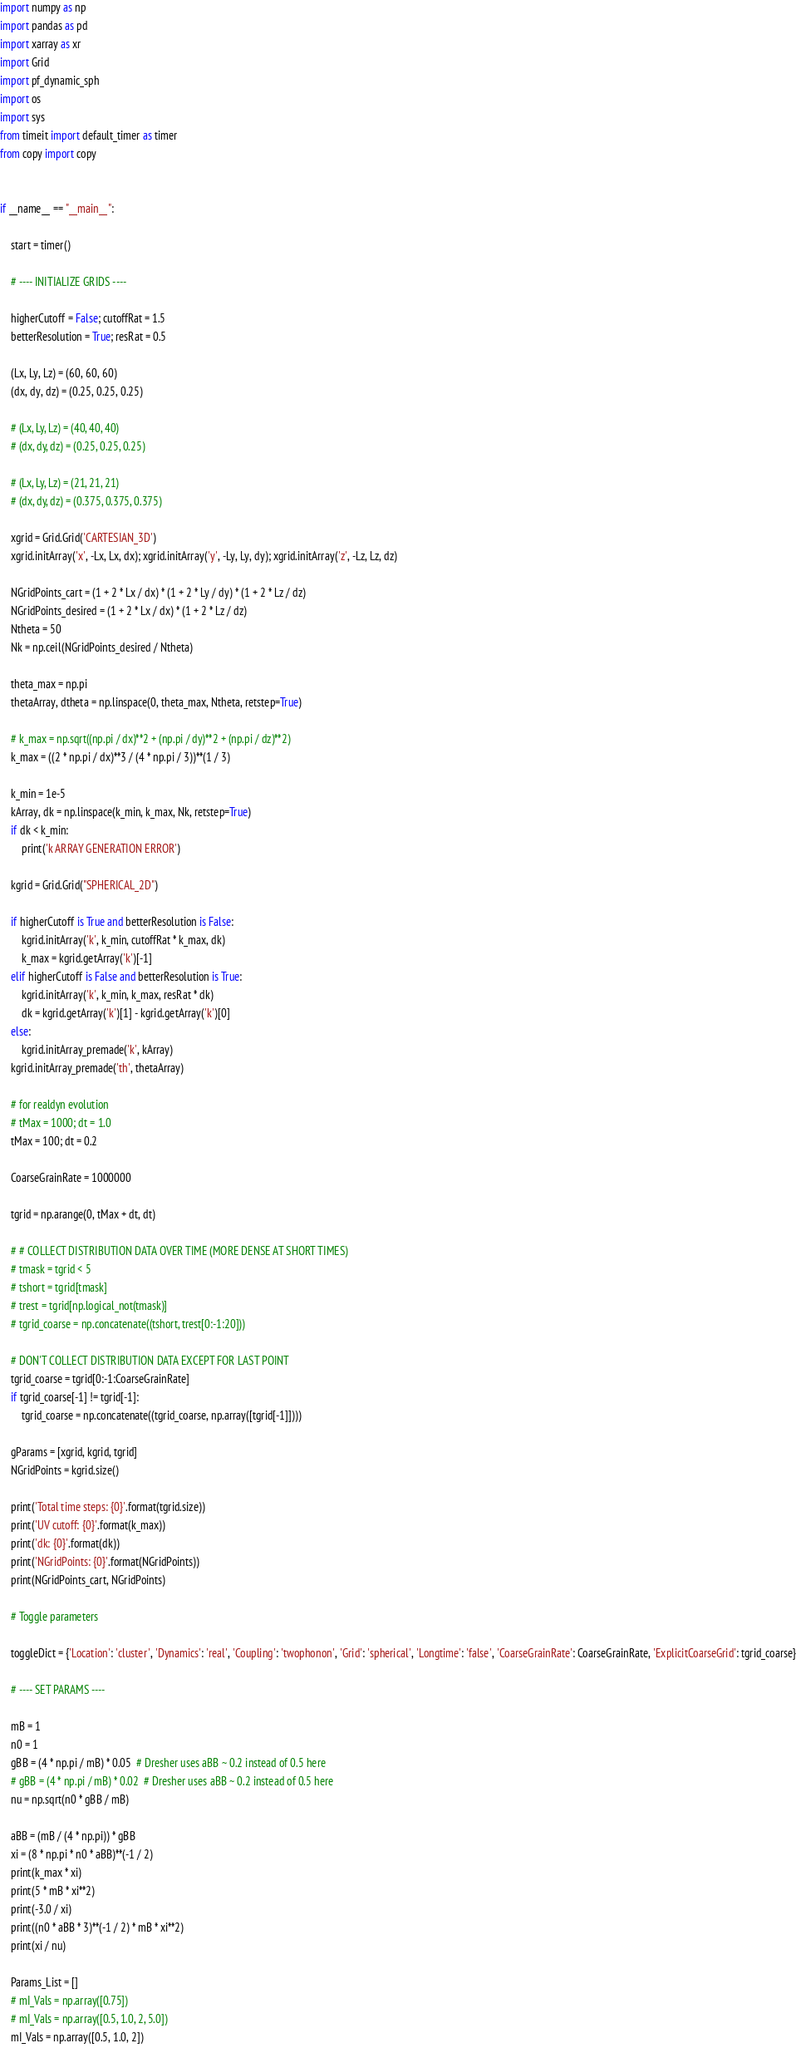Convert code to text. <code><loc_0><loc_0><loc_500><loc_500><_Python_>import numpy as np
import pandas as pd
import xarray as xr
import Grid
import pf_dynamic_sph
import os
import sys
from timeit import default_timer as timer
from copy import copy


if __name__ == "__main__":

    start = timer()

    # ---- INITIALIZE GRIDS ----

    higherCutoff = False; cutoffRat = 1.5
    betterResolution = True; resRat = 0.5

    (Lx, Ly, Lz) = (60, 60, 60)
    (dx, dy, dz) = (0.25, 0.25, 0.25)

    # (Lx, Ly, Lz) = (40, 40, 40)
    # (dx, dy, dz) = (0.25, 0.25, 0.25)

    # (Lx, Ly, Lz) = (21, 21, 21)
    # (dx, dy, dz) = (0.375, 0.375, 0.375)

    xgrid = Grid.Grid('CARTESIAN_3D')
    xgrid.initArray('x', -Lx, Lx, dx); xgrid.initArray('y', -Ly, Ly, dy); xgrid.initArray('z', -Lz, Lz, dz)

    NGridPoints_cart = (1 + 2 * Lx / dx) * (1 + 2 * Ly / dy) * (1 + 2 * Lz / dz)
    NGridPoints_desired = (1 + 2 * Lx / dx) * (1 + 2 * Lz / dz)
    Ntheta = 50
    Nk = np.ceil(NGridPoints_desired / Ntheta)

    theta_max = np.pi
    thetaArray, dtheta = np.linspace(0, theta_max, Ntheta, retstep=True)

    # k_max = np.sqrt((np.pi / dx)**2 + (np.pi / dy)**2 + (np.pi / dz)**2)
    k_max = ((2 * np.pi / dx)**3 / (4 * np.pi / 3))**(1 / 3)

    k_min = 1e-5
    kArray, dk = np.linspace(k_min, k_max, Nk, retstep=True)
    if dk < k_min:
        print('k ARRAY GENERATION ERROR')

    kgrid = Grid.Grid("SPHERICAL_2D")

    if higherCutoff is True and betterResolution is False:
        kgrid.initArray('k', k_min, cutoffRat * k_max, dk)
        k_max = kgrid.getArray('k')[-1]
    elif higherCutoff is False and betterResolution is True:
        kgrid.initArray('k', k_min, k_max, resRat * dk)
        dk = kgrid.getArray('k')[1] - kgrid.getArray('k')[0]
    else:
        kgrid.initArray_premade('k', kArray)
    kgrid.initArray_premade('th', thetaArray)

    # for realdyn evolution
    # tMax = 1000; dt = 1.0
    tMax = 100; dt = 0.2

    CoarseGrainRate = 1000000

    tgrid = np.arange(0, tMax + dt, dt)

    # # COLLECT DISTRIBUTION DATA OVER TIME (MORE DENSE AT SHORT TIMES)
    # tmask = tgrid < 5
    # tshort = tgrid[tmask]
    # trest = tgrid[np.logical_not(tmask)]
    # tgrid_coarse = np.concatenate((tshort, trest[0:-1:20]))

    # DON'T COLLECT DISTRIBUTION DATA EXCEPT FOR LAST POINT
    tgrid_coarse = tgrid[0:-1:CoarseGrainRate]
    if tgrid_coarse[-1] != tgrid[-1]:
        tgrid_coarse = np.concatenate((tgrid_coarse, np.array([tgrid[-1]])))

    gParams = [xgrid, kgrid, tgrid]
    NGridPoints = kgrid.size()

    print('Total time steps: {0}'.format(tgrid.size))
    print('UV cutoff: {0}'.format(k_max))
    print('dk: {0}'.format(dk))
    print('NGridPoints: {0}'.format(NGridPoints))
    print(NGridPoints_cart, NGridPoints)

    # Toggle parameters

    toggleDict = {'Location': 'cluster', 'Dynamics': 'real', 'Coupling': 'twophonon', 'Grid': 'spherical', 'Longtime': 'false', 'CoarseGrainRate': CoarseGrainRate, 'ExplicitCoarseGrid': tgrid_coarse}

    # ---- SET PARAMS ----

    mB = 1
    n0 = 1
    gBB = (4 * np.pi / mB) * 0.05  # Dresher uses aBB ~ 0.2 instead of 0.5 here
    # gBB = (4 * np.pi / mB) * 0.02  # Dresher uses aBB ~ 0.2 instead of 0.5 here
    nu = np.sqrt(n0 * gBB / mB)

    aBB = (mB / (4 * np.pi)) * gBB
    xi = (8 * np.pi * n0 * aBB)**(-1 / 2)
    print(k_max * xi)
    print(5 * mB * xi**2)
    print(-3.0 / xi)
    print((n0 * aBB * 3)**(-1 / 2) * mB * xi**2)
    print(xi / nu)

    Params_List = []
    # mI_Vals = np.array([0.75])
    # mI_Vals = np.array([0.5, 1.0, 2, 5.0])
    mI_Vals = np.array([0.5, 1.0, 2])</code> 